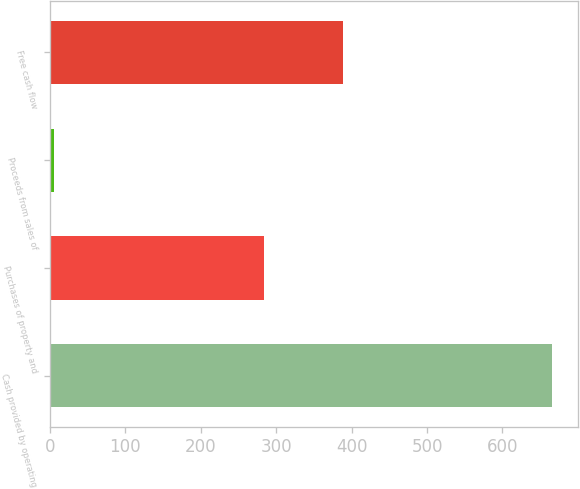Convert chart. <chart><loc_0><loc_0><loc_500><loc_500><bar_chart><fcel>Cash provided by operating<fcel>Purchases of property and<fcel>Proceeds from sales of<fcel>Free cash flow<nl><fcel>666.3<fcel>283.8<fcel>5.7<fcel>388.2<nl></chart> 